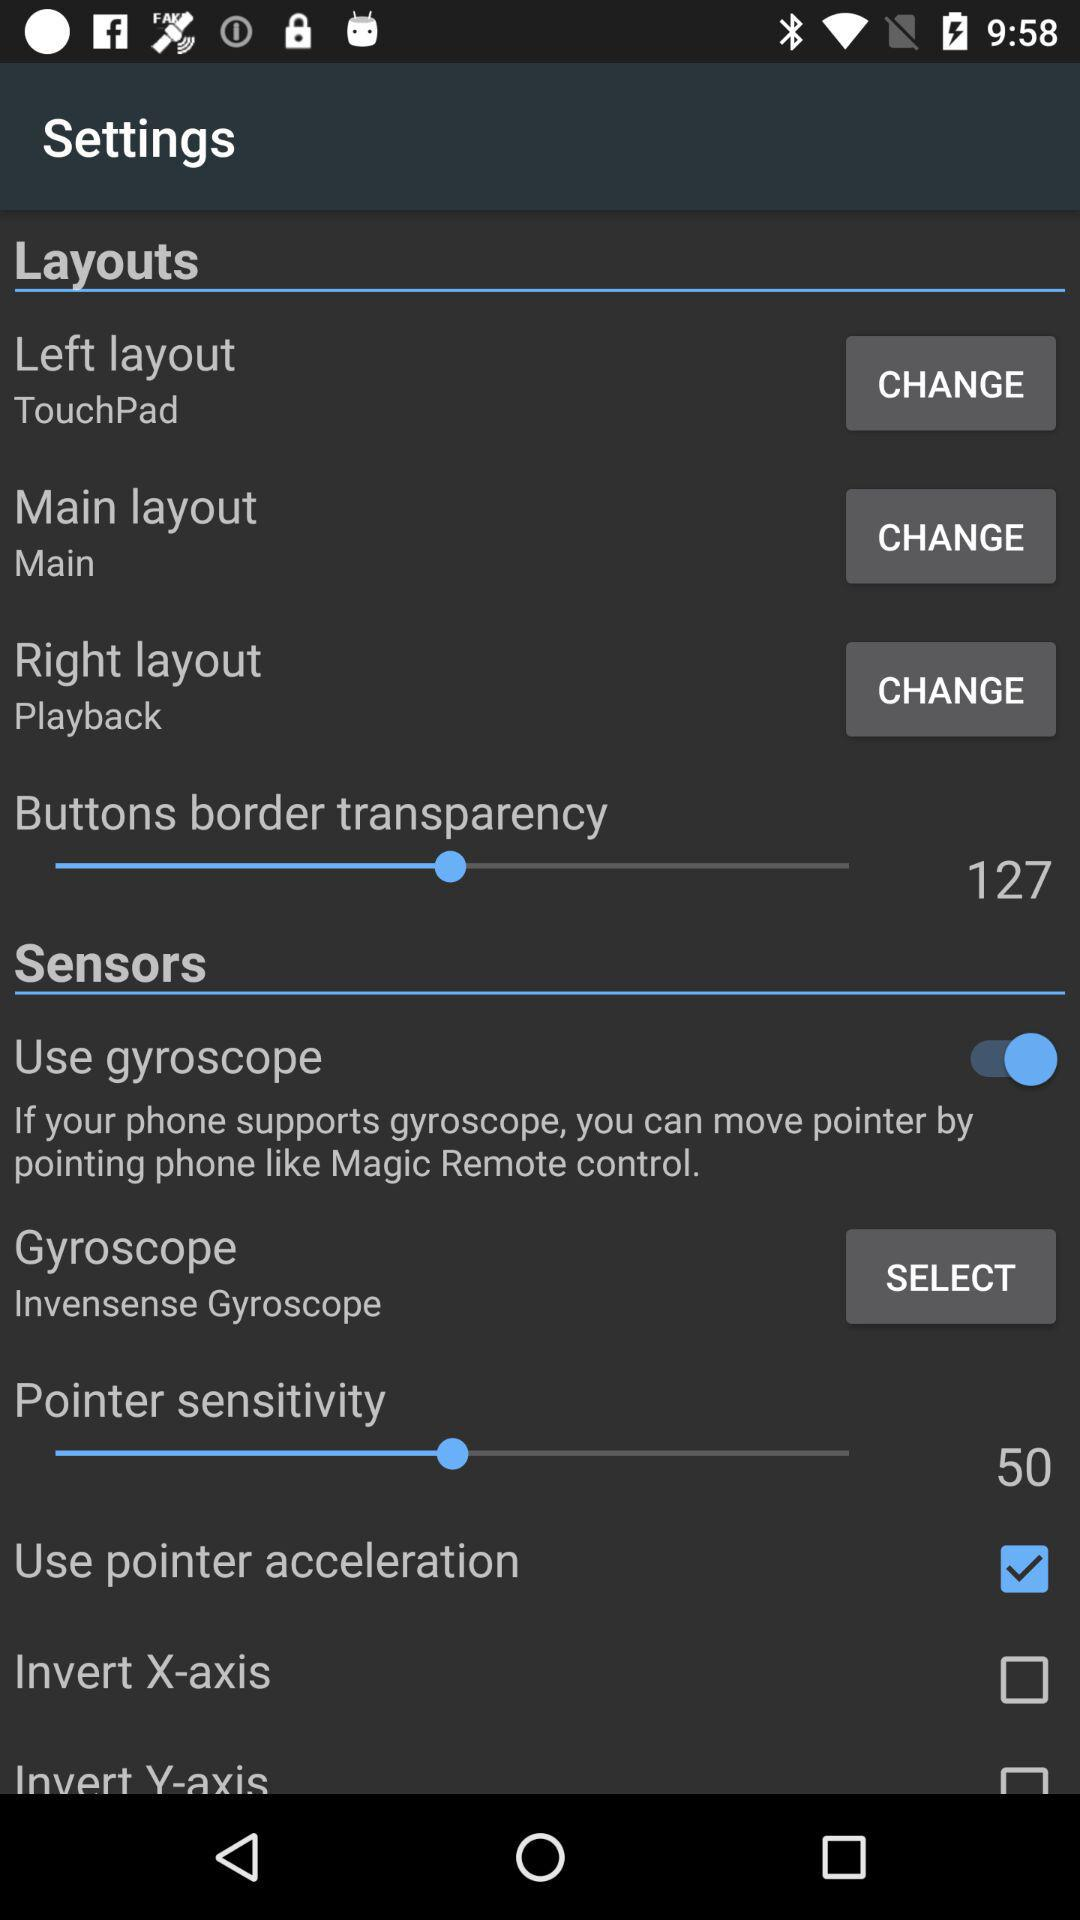How many items are in the Layouts section?
Answer the question using a single word or phrase. 3 